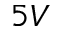Convert formula to latex. <formula><loc_0><loc_0><loc_500><loc_500>5 V</formula> 